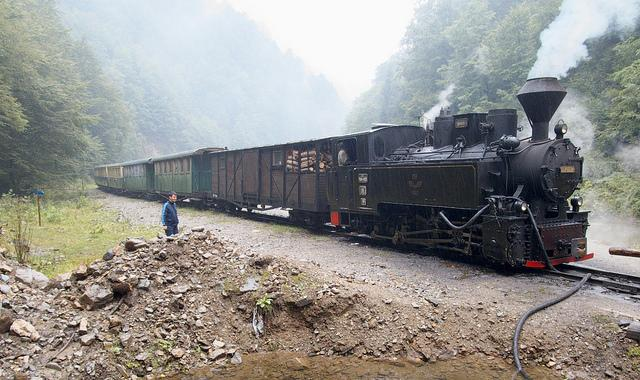What is being used to maintain the steam engine's momentum? coal 